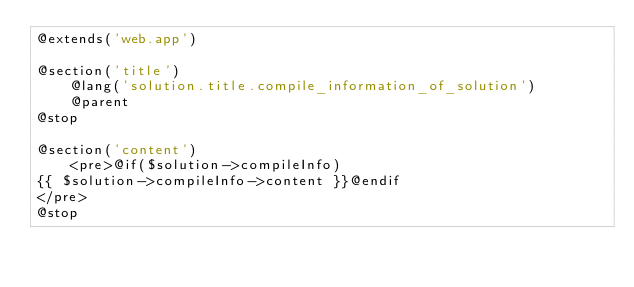Convert code to text. <code><loc_0><loc_0><loc_500><loc_500><_PHP_>@extends('web.app')

@section('title')
    @lang('solution.title.compile_information_of_solution')
    @parent
@stop

@section('content')
    <pre>@if($solution->compileInfo)
{{ $solution->compileInfo->content }}@endif
</pre>
@stop
</code> 